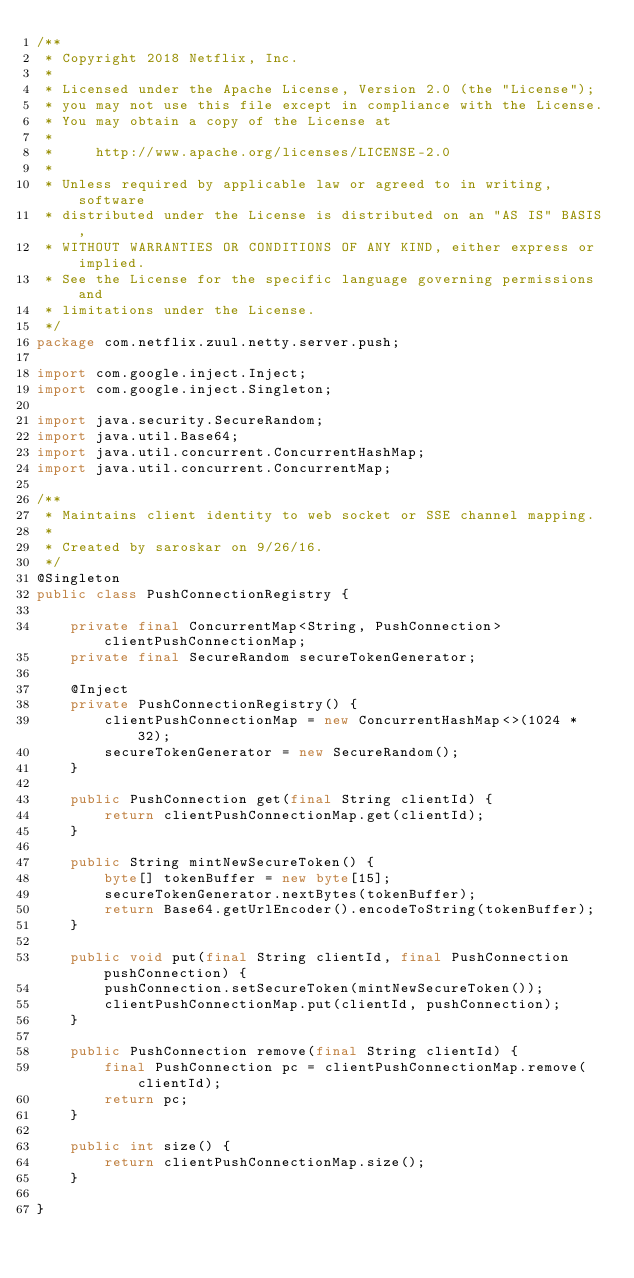Convert code to text. <code><loc_0><loc_0><loc_500><loc_500><_Java_>/**
 * Copyright 2018 Netflix, Inc.
 *
 * Licensed under the Apache License, Version 2.0 (the "License");
 * you may not use this file except in compliance with the License.
 * You may obtain a copy of the License at
 *
 *     http://www.apache.org/licenses/LICENSE-2.0
 *
 * Unless required by applicable law or agreed to in writing, software
 * distributed under the License is distributed on an "AS IS" BASIS,
 * WITHOUT WARRANTIES OR CONDITIONS OF ANY KIND, either express or implied.
 * See the License for the specific language governing permissions and
 * limitations under the License.
 */
package com.netflix.zuul.netty.server.push;

import com.google.inject.Inject;
import com.google.inject.Singleton;

import java.security.SecureRandom;
import java.util.Base64;
import java.util.concurrent.ConcurrentHashMap;
import java.util.concurrent.ConcurrentMap;

/**
 * Maintains client identity to web socket or SSE channel mapping.
 *
 * Created by saroskar on 9/26/16.
 */
@Singleton
public class PushConnectionRegistry {

    private final ConcurrentMap<String, PushConnection> clientPushConnectionMap;
    private final SecureRandom secureTokenGenerator;

    @Inject
    private PushConnectionRegistry() {
        clientPushConnectionMap = new ConcurrentHashMap<>(1024 * 32);
        secureTokenGenerator = new SecureRandom();
    }

    public PushConnection get(final String clientId) {
        return clientPushConnectionMap.get(clientId);
    }

    public String mintNewSecureToken() {
        byte[] tokenBuffer = new byte[15];
        secureTokenGenerator.nextBytes(tokenBuffer);
        return Base64.getUrlEncoder().encodeToString(tokenBuffer);
    }

    public void put(final String clientId, final PushConnection pushConnection) {
        pushConnection.setSecureToken(mintNewSecureToken());
        clientPushConnectionMap.put(clientId, pushConnection);
    }

    public PushConnection remove(final String clientId) {
        final PushConnection pc = clientPushConnectionMap.remove(clientId);
        return pc;
    }

    public int size() {
        return clientPushConnectionMap.size();
    }

}
</code> 